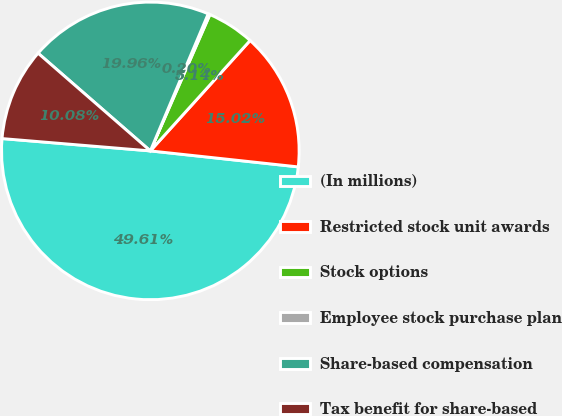Convert chart. <chart><loc_0><loc_0><loc_500><loc_500><pie_chart><fcel>(In millions)<fcel>Restricted stock unit awards<fcel>Stock options<fcel>Employee stock purchase plan<fcel>Share-based compensation<fcel>Tax benefit for share-based<nl><fcel>49.61%<fcel>15.02%<fcel>5.14%<fcel>0.2%<fcel>19.96%<fcel>10.08%<nl></chart> 